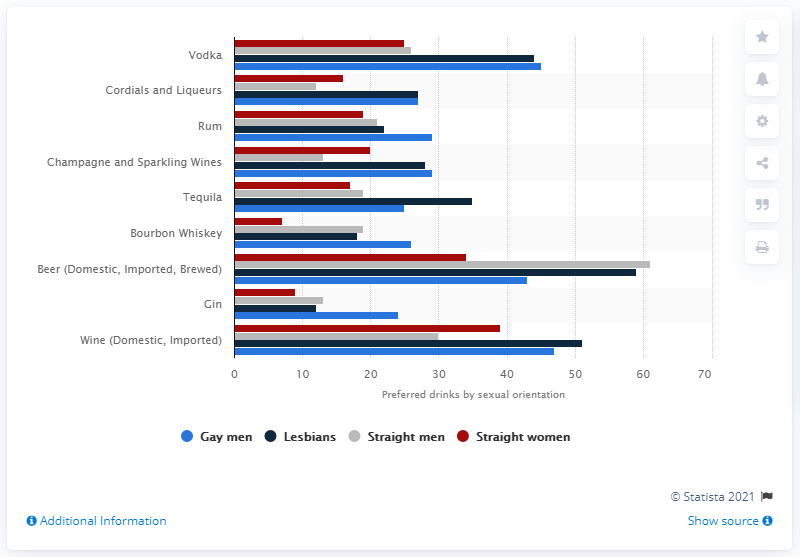Outline some significant characteristics in this image. According to a survey of lesbians, 44% reported drinking Vodka. According to the survey results, 45% of gay and lesbian respondents reported drinking Vodka. 